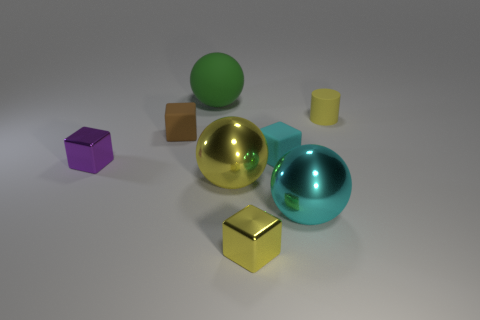Subtract all big green balls. How many balls are left? 2 Add 1 tiny rubber objects. How many objects exist? 9 Subtract all purple cubes. How many cubes are left? 3 Subtract all blue blocks. Subtract all yellow cylinders. How many blocks are left? 4 Subtract all balls. How many objects are left? 5 Subtract 0 brown cylinders. How many objects are left? 8 Subtract all large matte things. Subtract all purple metallic blocks. How many objects are left? 6 Add 1 large cyan balls. How many large cyan balls are left? 2 Add 3 tiny cyan cubes. How many tiny cyan cubes exist? 4 